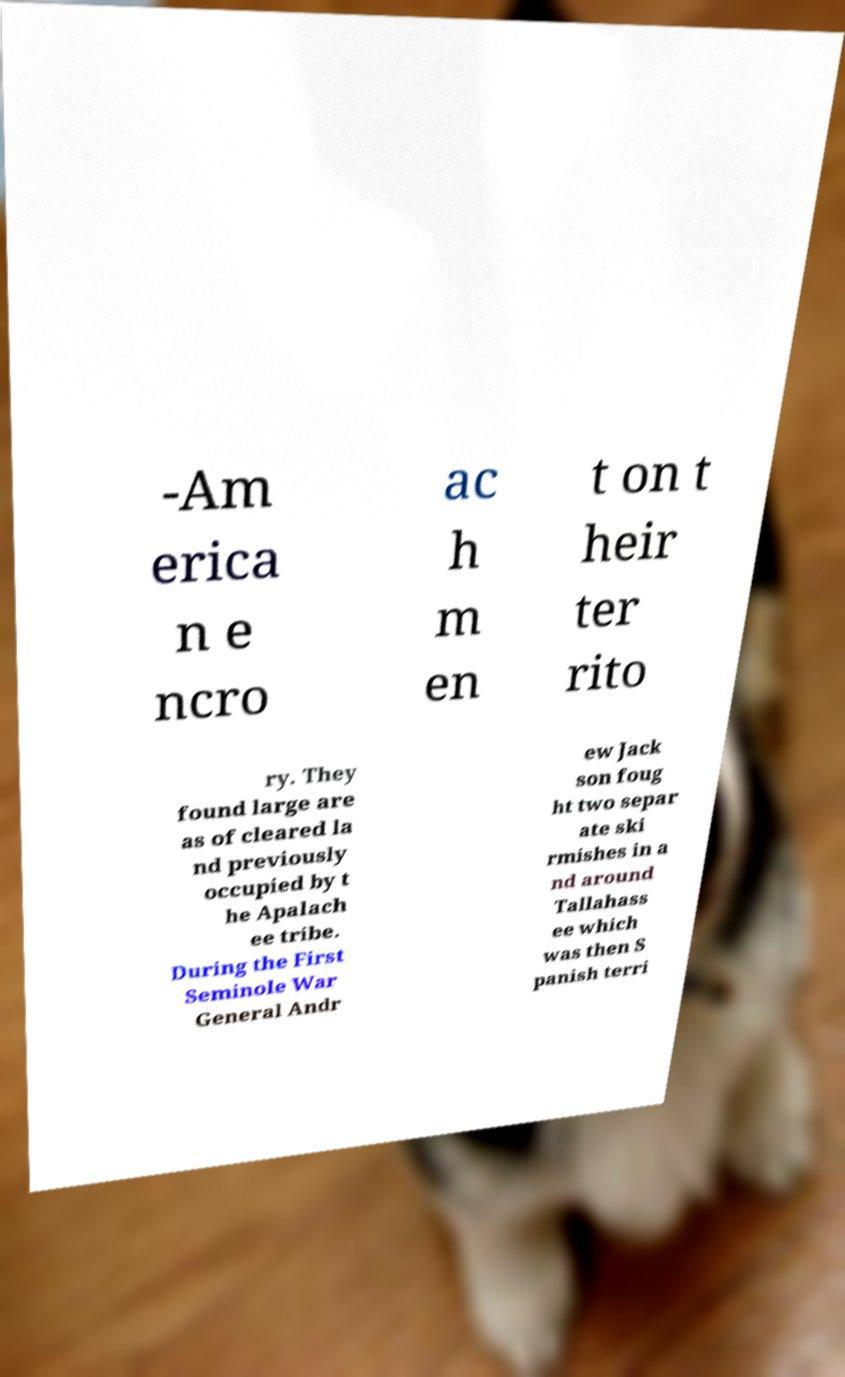For documentation purposes, I need the text within this image transcribed. Could you provide that? -Am erica n e ncro ac h m en t on t heir ter rito ry. They found large are as of cleared la nd previously occupied by t he Apalach ee tribe. During the First Seminole War General Andr ew Jack son foug ht two separ ate ski rmishes in a nd around Tallahass ee which was then S panish terri 